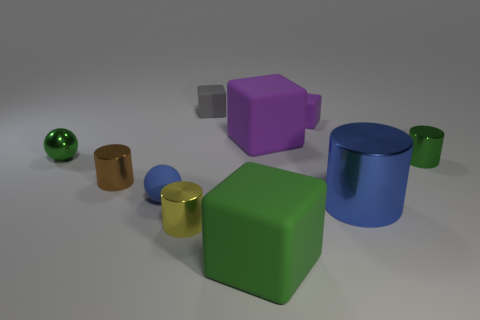Do the small purple object and the small green shiny thing left of the large green matte thing have the same shape?
Offer a very short reply. No. The metal thing on the left side of the brown metal object has what shape?
Provide a short and direct response. Sphere. Is the shape of the brown object the same as the small yellow metal object?
Keep it short and to the point. Yes. What is the size of the blue metal thing that is the same shape as the tiny brown shiny object?
Provide a short and direct response. Large. There is a ball behind the brown cylinder; is its size the same as the small gray matte thing?
Ensure brevity in your answer.  Yes. There is a thing that is both behind the green metal ball and to the right of the big purple cube; what is its size?
Your answer should be very brief. Small. There is a ball that is the same color as the big cylinder; what material is it?
Your answer should be very brief. Rubber. What number of large cylinders are the same color as the small rubber sphere?
Give a very brief answer. 1. Are there the same number of small gray matte things in front of the gray object and tiny gray matte blocks?
Your response must be concise. No. The large cylinder is what color?
Your answer should be very brief. Blue. 